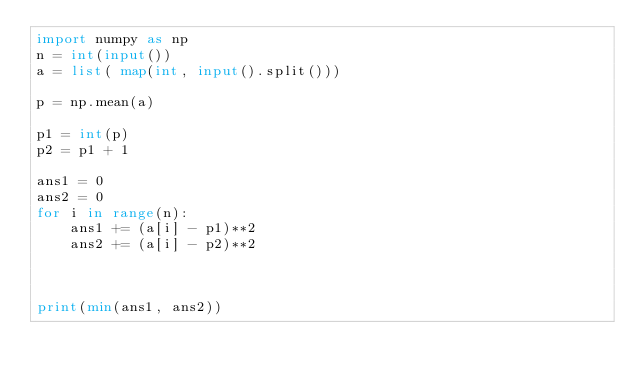Convert code to text. <code><loc_0><loc_0><loc_500><loc_500><_Python_>import numpy as np
n = int(input())
a = list( map(int, input().split()))

p = np.mean(a)

p1 = int(p)
p2 = p1 + 1

ans1 = 0
ans2 = 0
for i in range(n):
    ans1 += (a[i] - p1)**2
    ans2 += (a[i] - p2)**2



print(min(ans1, ans2))</code> 